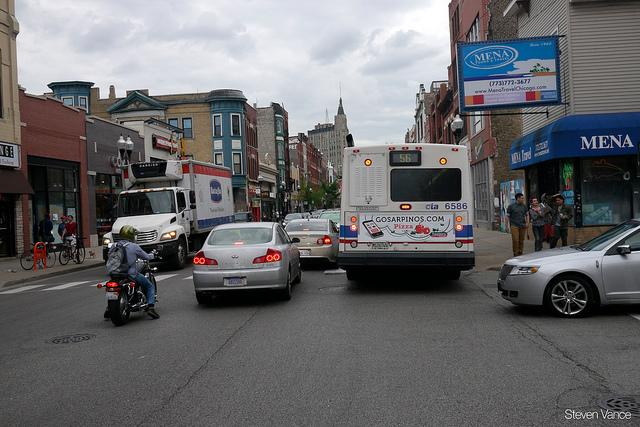Which vehicle stuck in the intersection is in the most danger?

Choices:
A) truck
B) car
C) bus
D) motorcycle motorcycle 